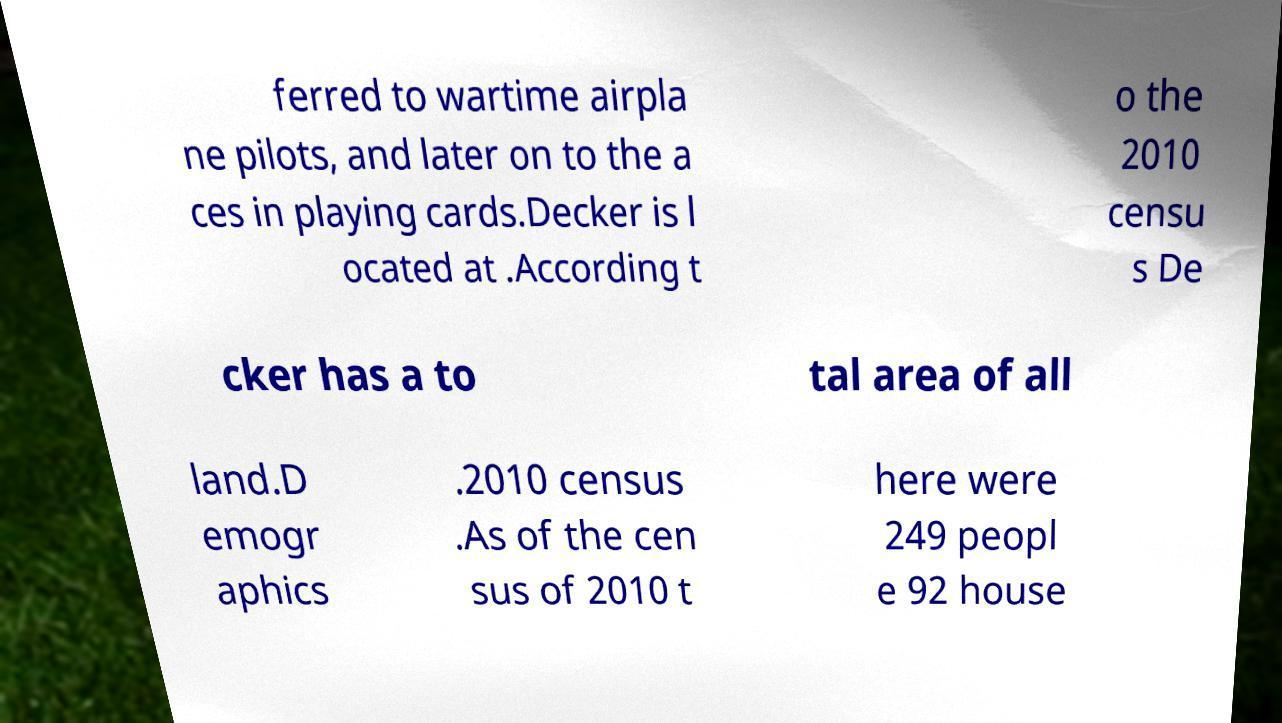I need the written content from this picture converted into text. Can you do that? ferred to wartime airpla ne pilots, and later on to the a ces in playing cards.Decker is l ocated at .According t o the 2010 censu s De cker has a to tal area of all land.D emogr aphics .2010 census .As of the cen sus of 2010 t here were 249 peopl e 92 house 